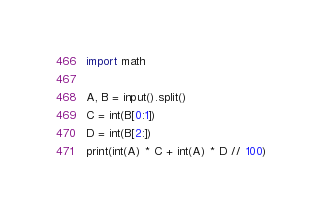Convert code to text. <code><loc_0><loc_0><loc_500><loc_500><_Python_>import math

A, B = input().split()
C = int(B[0:1])
D = int(B[2:])
print(int(A) * C + int(A) * D // 100)</code> 